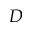<formula> <loc_0><loc_0><loc_500><loc_500>D</formula> 